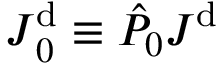Convert formula to latex. <formula><loc_0><loc_0><loc_500><loc_500>J _ { 0 } ^ { d } \equiv \hat { P } _ { 0 } J ^ { d }</formula> 